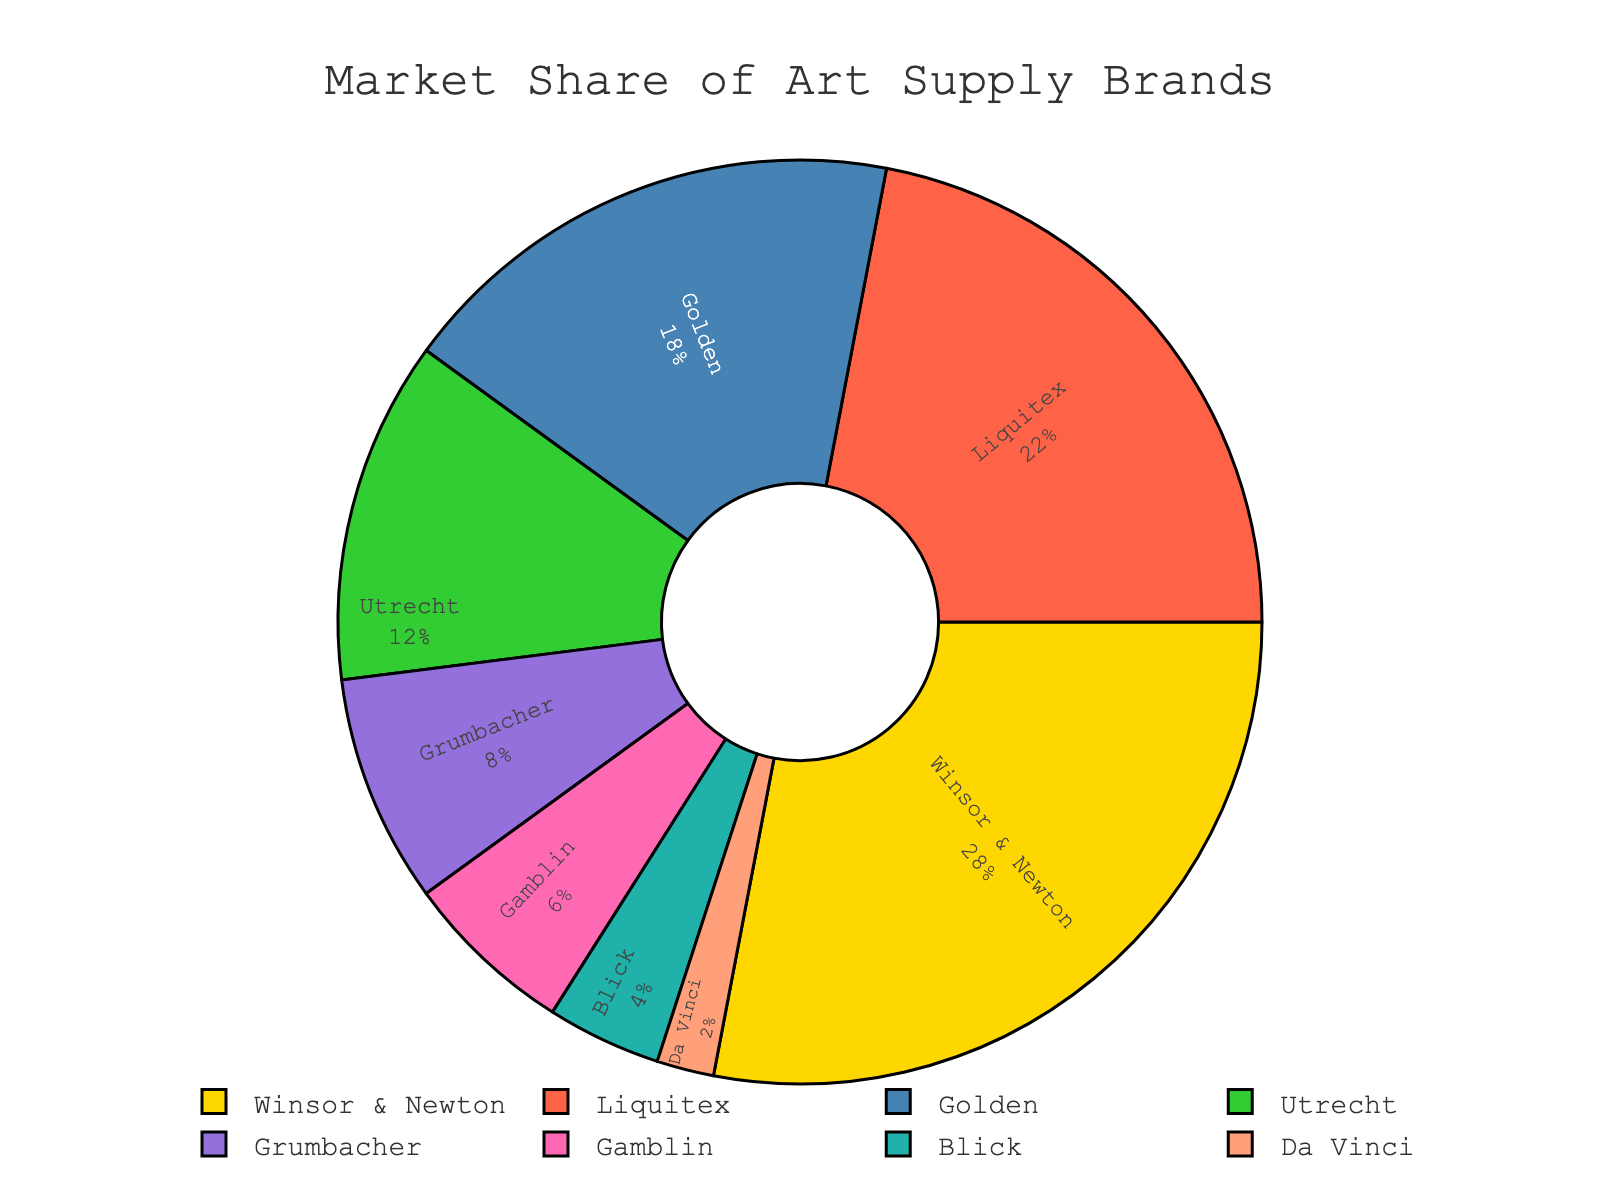What percentage of the market share does Winsor & Newton have? Winsor & Newton's label on the pie chart shows its market share percentage.
Answer: 28% Is Liquitex's market share greater than Golden's? Compare the market share percentages of Liquitex (22%) and Golden (18%) as shown on the pie chart. Liquitex has a higher percentage.
Answer: Yes What is the total market share of Utrecht, Grumbacher, and Gamblin? Add up the market shares of Utrecht (12%), Grumbacher (8%), and Gamblin (6%). The total is 12 + 8 + 6 = 26%.
Answer: 26% Which brand has the smallest market share? Look for the brand with the smallest percentage in the pie chart. Da Vinci has the smallest market share with 2%.
Answer: Da Vinci Is Utrecht's market share less than half of Winsor & Newton's? Utrecht's market share is 12%. Half of Winsor & Newton's market share (28%) is 14%. Since 12% is less than 14%, Utrecht's market share is less than half of Winsor & Newton's.
Answer: Yes What color represents Liquitex on the pie chart? Identify the color associated with Liquitex on the pie chart. It is red.
Answer: Red What is the difference in market share between the top and bottom brands? Subtract the market share of Da Vinci (2%) from Winsor & Newton (28%). The difference is 28 - 2 = 26%.
Answer: 26% What is the combined market share of the top three brands? Add the market shares of Winsor & Newton (28%), Liquitex (22%), and Golden (18%). The total is 28 + 22 + 18 = 68%.
Answer: 68% How many brands have a market share above 10%? Identify the brands with market shares above 10%: Winsor & Newton (28%), Liquitex (22%), Golden (18%), and Utrecht (12%). There are four brands.
Answer: 4 